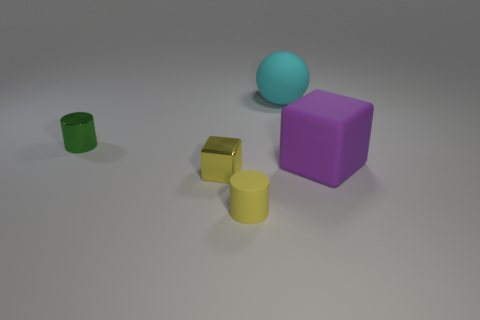Add 1 purple rubber cubes. How many objects exist? 6 Subtract all spheres. How many objects are left? 4 Subtract 1 yellow cubes. How many objects are left? 4 Subtract all small green metal objects. Subtract all green metal objects. How many objects are left? 3 Add 3 small things. How many small things are left? 6 Add 4 green rubber spheres. How many green rubber spheres exist? 4 